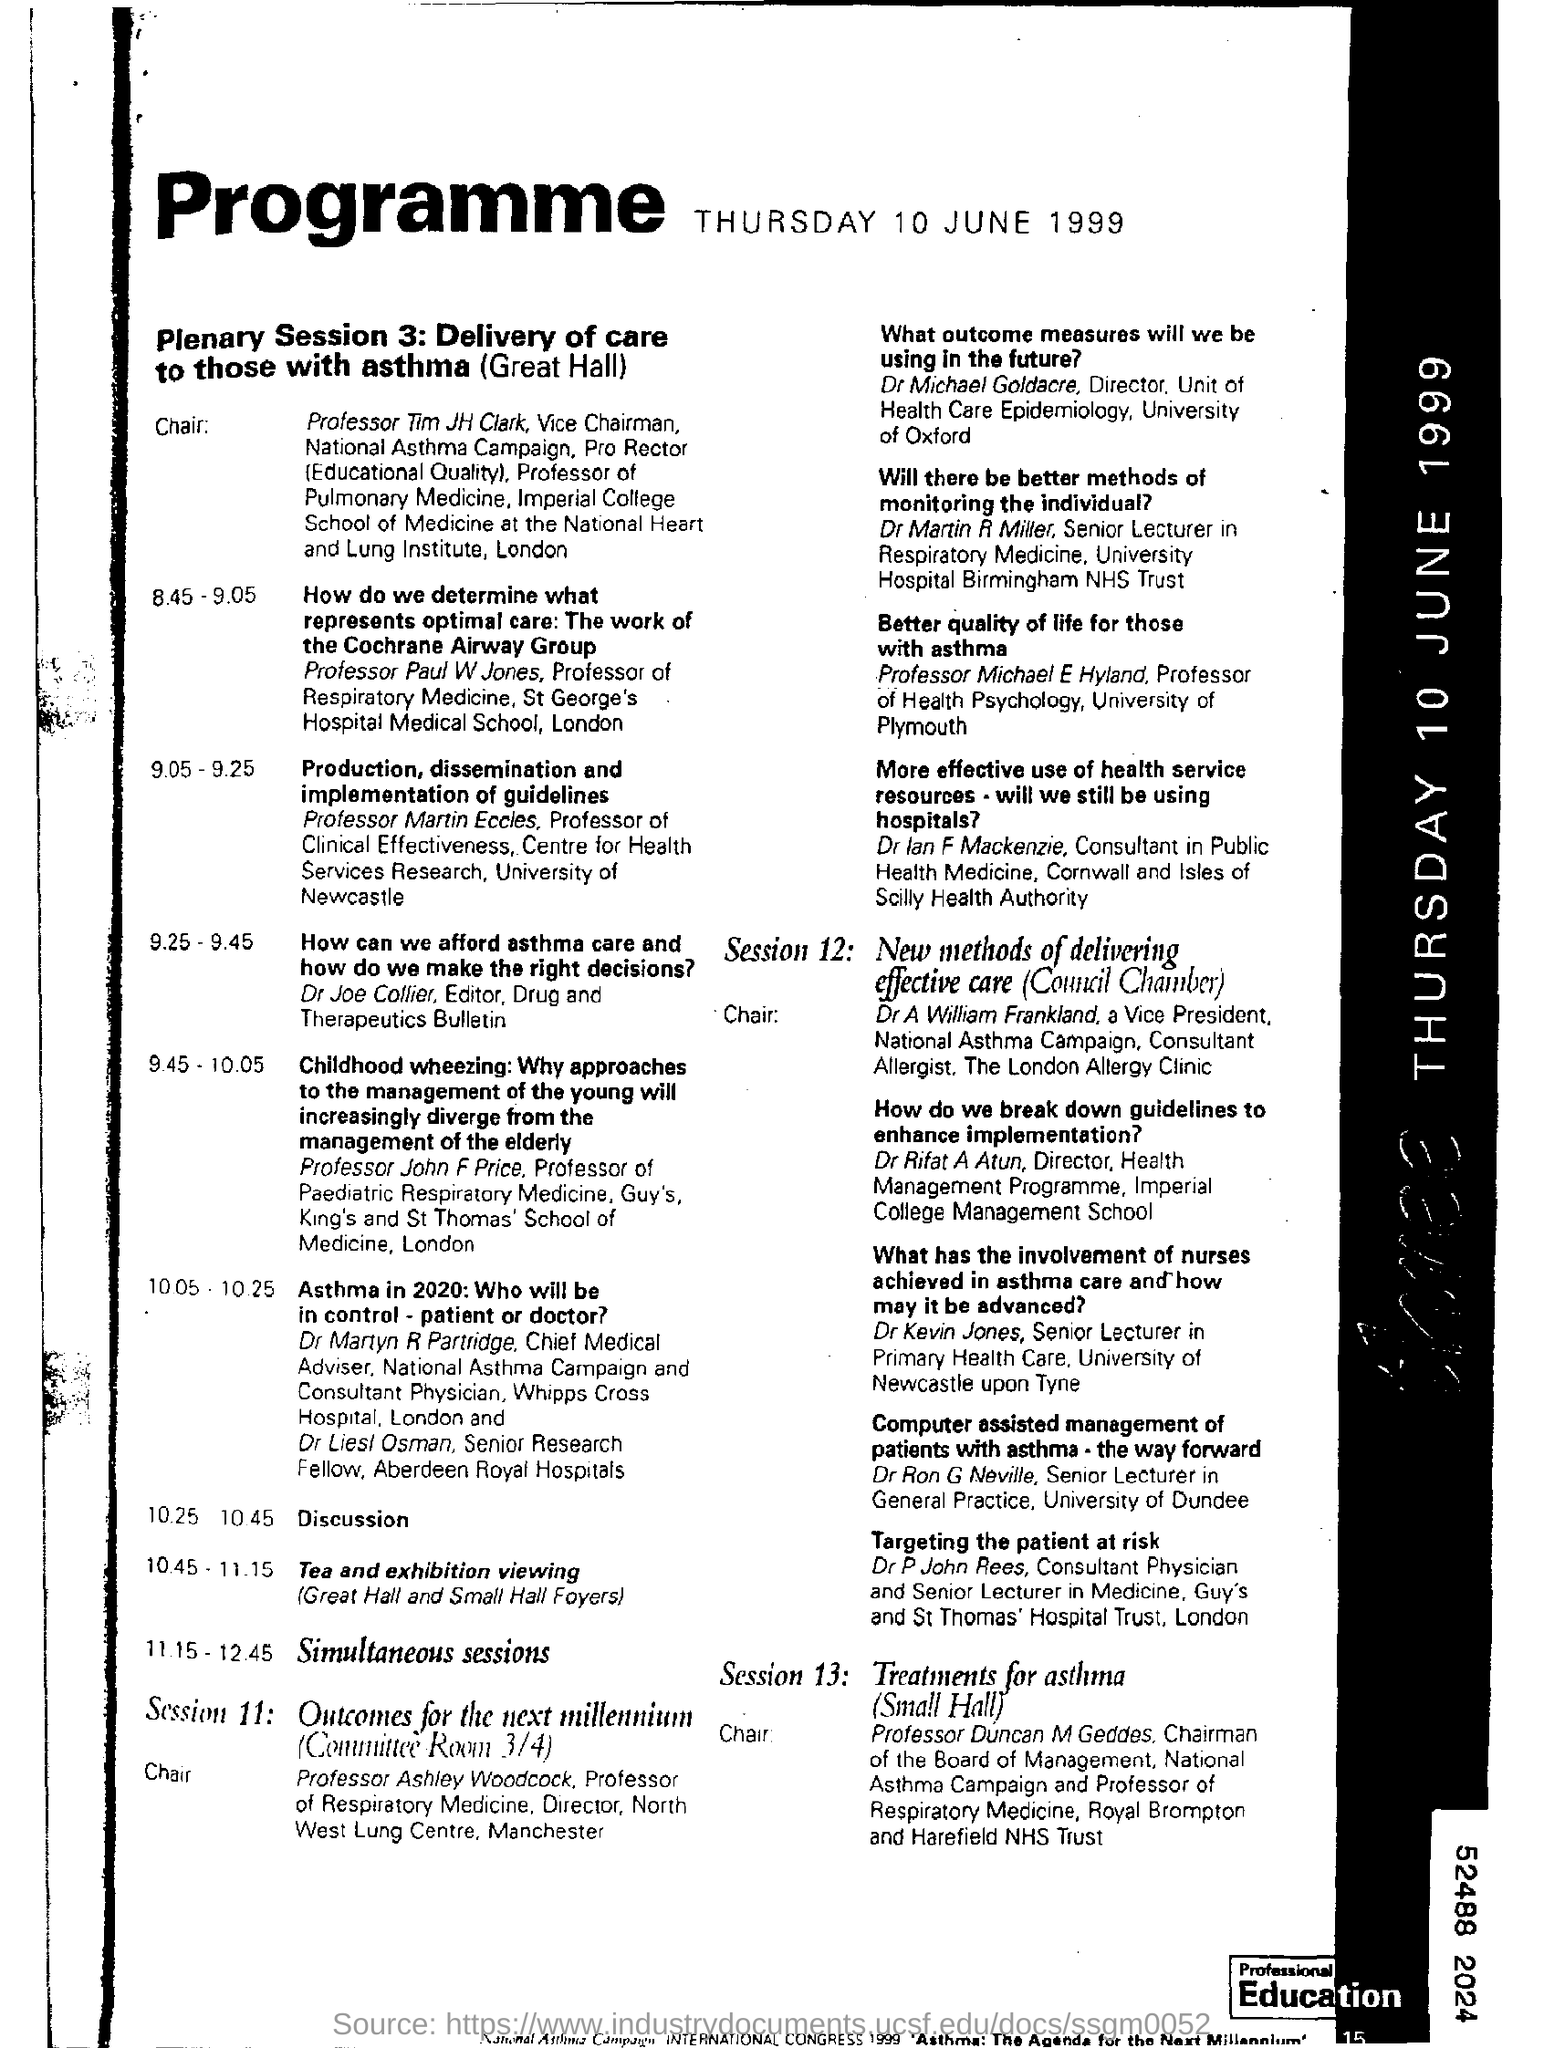Point out several critical features in this image. The program will be held on Thursday, June 10, 1999. The location of Session 11 shall be held in Committee Room 3/4. The Plenary session 3 is about the delivery of care to individuals with asthma. Dr. Joe Collier is an editor for the Drug and Therapeutics Bulletin. Session 12 will discuss new methods for delivering effective care, specifically in council chambers. 